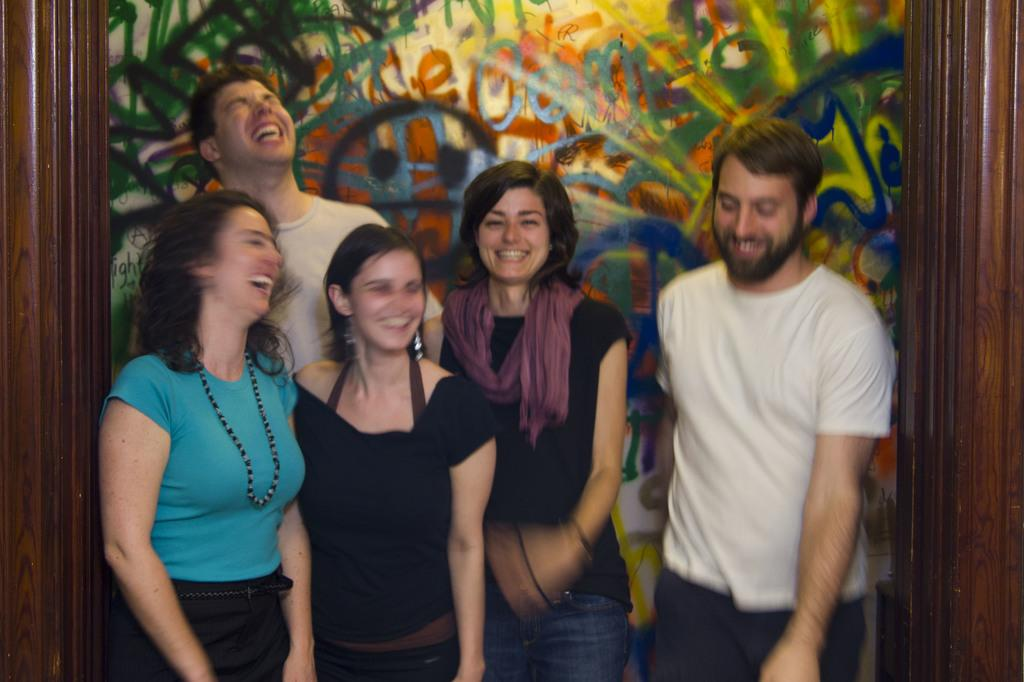What are the people in the image doing? The people in the image are standing in the center and smiling. What can be seen in the background of the image? There is a wooden wall and a banner in the background of the image. What type of floor can be seen in the image? There is no floor visible in the image; it only shows people standing and a background with a wooden wall and a banner. Who is the manager in the image? There is no mention of a manager in the image or the provided facts. 